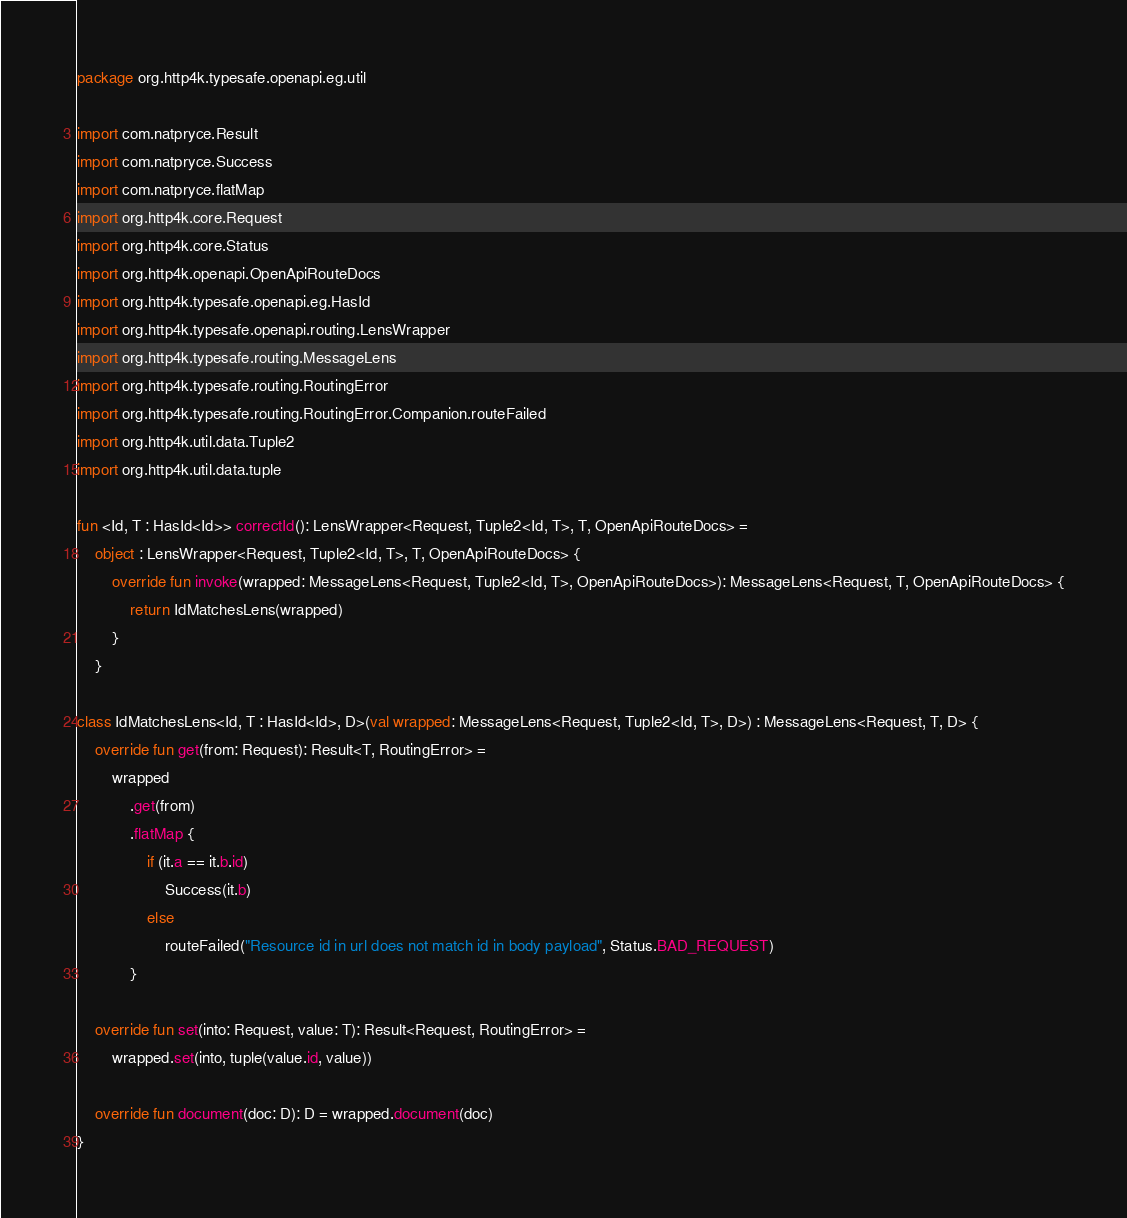Convert code to text. <code><loc_0><loc_0><loc_500><loc_500><_Kotlin_>package org.http4k.typesafe.openapi.eg.util

import com.natpryce.Result
import com.natpryce.Success
import com.natpryce.flatMap
import org.http4k.core.Request
import org.http4k.core.Status
import org.http4k.openapi.OpenApiRouteDocs
import org.http4k.typesafe.openapi.eg.HasId
import org.http4k.typesafe.openapi.routing.LensWrapper
import org.http4k.typesafe.routing.MessageLens
import org.http4k.typesafe.routing.RoutingError
import org.http4k.typesafe.routing.RoutingError.Companion.routeFailed
import org.http4k.util.data.Tuple2
import org.http4k.util.data.tuple

fun <Id, T : HasId<Id>> correctId(): LensWrapper<Request, Tuple2<Id, T>, T, OpenApiRouteDocs> =
    object : LensWrapper<Request, Tuple2<Id, T>, T, OpenApiRouteDocs> {
        override fun invoke(wrapped: MessageLens<Request, Tuple2<Id, T>, OpenApiRouteDocs>): MessageLens<Request, T, OpenApiRouteDocs> {
            return IdMatchesLens(wrapped)
        }
    }

class IdMatchesLens<Id, T : HasId<Id>, D>(val wrapped: MessageLens<Request, Tuple2<Id, T>, D>) : MessageLens<Request, T, D> {
    override fun get(from: Request): Result<T, RoutingError> =
        wrapped
            .get(from)
            .flatMap {
                if (it.a == it.b.id)
                    Success(it.b)
                else
                    routeFailed("Resource id in url does not match id in body payload", Status.BAD_REQUEST)
            }

    override fun set(into: Request, value: T): Result<Request, RoutingError> =
        wrapped.set(into, tuple(value.id, value))

    override fun document(doc: D): D = wrapped.document(doc)
}
</code> 